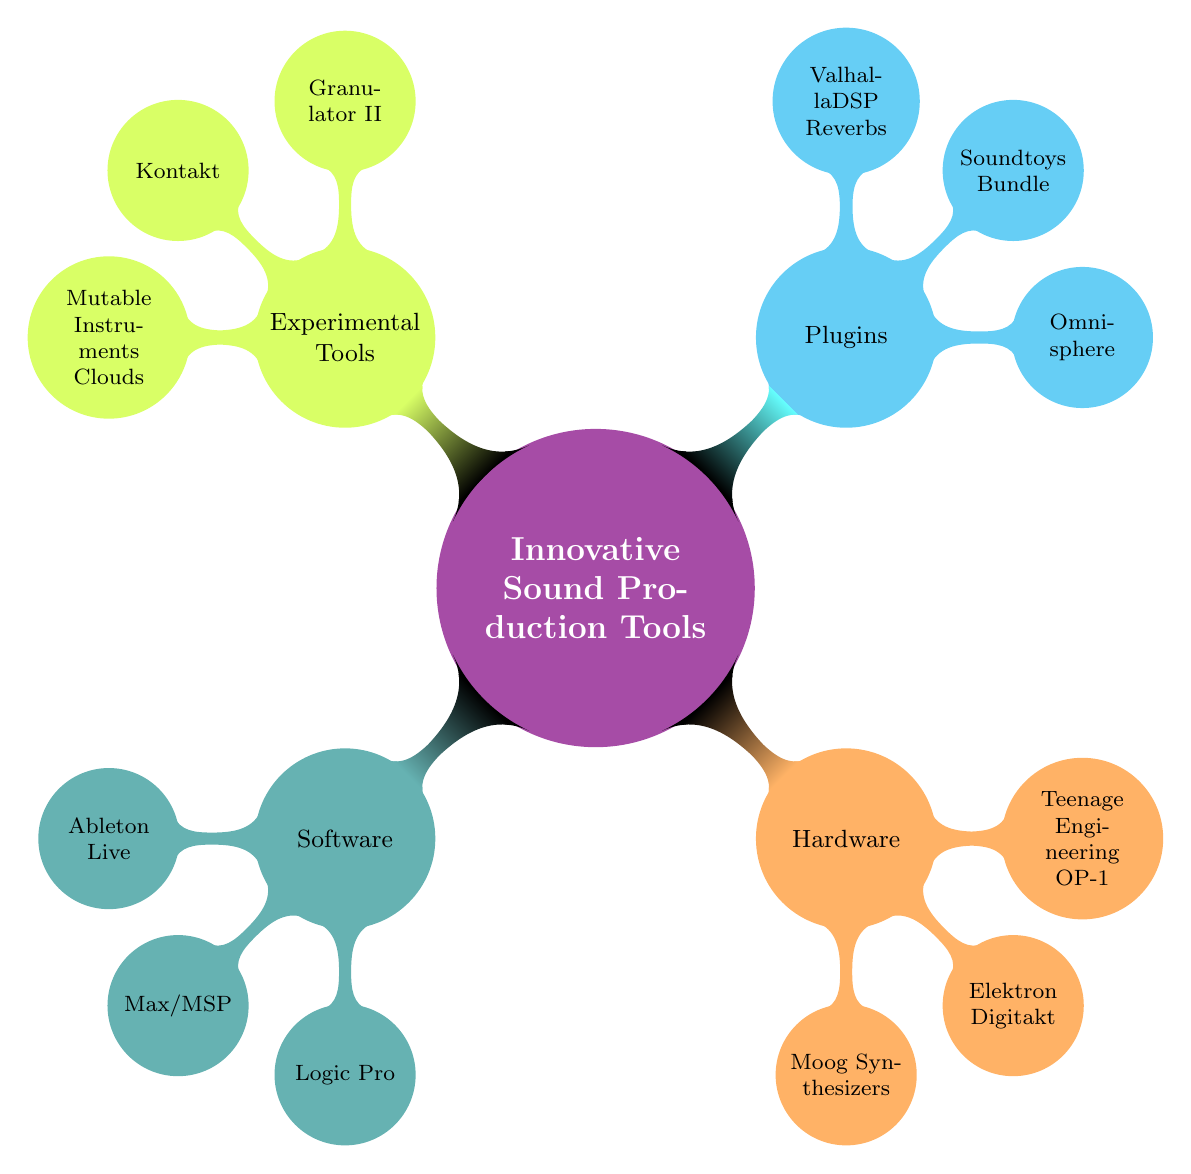What are the three main categories in the mind map? The main categories are Software, Hardware, Plugins, and Experimental Tools. These categories are the immediate children of the central node, 'Innovative Sound Production Tools'.
Answer: Software, Hardware, Plugins, Experimental Tools How many nodes are in the 'Software' category? The 'Software' category contains three nodes: Ableton Live, Max/MSP, and Logic Pro. Each represents a distinctive software option within the broader category.
Answer: 3 Which tool is specifically designed for granular synthesis? Granulator II is listed under the Experimental Tools category, identified specifically as a granular synthesis plugin for Ableton Live.
Answer: Granulator II What color represents the Hardware category? The color orange is used for the Hardware category, which denotes its unique group within the mind map structure, differentiating it from the other categories, which have their own colors.
Answer: Orange Which tools are located under the Experimental Tools category? The Experimental Tools category contains three nodes: Granulator II, Kontakt, and Mutable Instruments Clouds, showcasing a variety of innovative sound production tools in this specific area.
Answer: Granulator II, Kontakt, Mutable Instruments Clouds How many plugins are mentioned in the diagram? There are three plugins listed in the Plugins category: Omnisphere, Soundtoys Bundle, and ValhallaDSP Reverbs. Therefore, the total number of plugins mentioned is three.
Answer: 3 Which software is described as a powerhouse synthesizer plugin? Omnisphere is identified in the Plugins category and is described as a powerhouse synthesizer plugin ideal for creating complex and textured sounds.
Answer: Omnisphere What is the maximum level of branches from the 'Innovative Sound Production Tools'? The diagram shows a maximum of two levels: the first level contains four categories and the second level shows the tools under each category. thus, the maximum is 2.
Answer: 2 